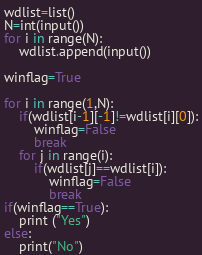Convert code to text. <code><loc_0><loc_0><loc_500><loc_500><_Python_>wdlist=list()
N=int(input())
for i in range(N):
	wdlist.append(input())

winflag=True

for i in range(1,N):
	if(wdlist[i-1][-1]!=wdlist[i][0]):
		winflag=False
		break
	for j in range(i):
		if(wdlist[j]==wdlist[i]):
			winflag=False
			break
if(winflag==True):
	print ("Yes")
else:
	print("No")
</code> 